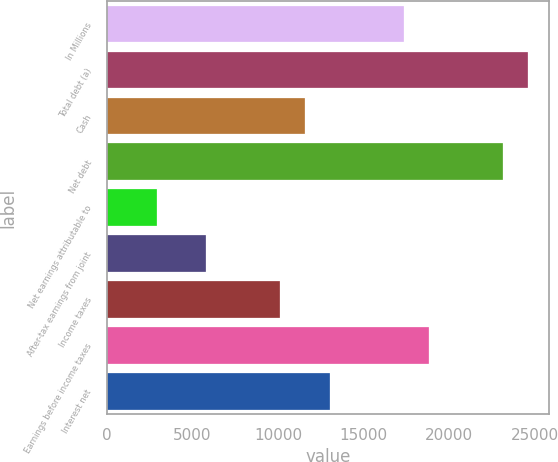Convert chart. <chart><loc_0><loc_0><loc_500><loc_500><bar_chart><fcel>In Millions<fcel>Total debt (a)<fcel>Cash<fcel>Net debt<fcel>Net earnings attributable to<fcel>After-tax earnings from joint<fcel>Income taxes<fcel>Earnings before income taxes<fcel>Interest net<nl><fcel>17387.7<fcel>24632.1<fcel>11592.3<fcel>23183.2<fcel>2899.04<fcel>5796.78<fcel>10143.4<fcel>18836.6<fcel>13041.1<nl></chart> 